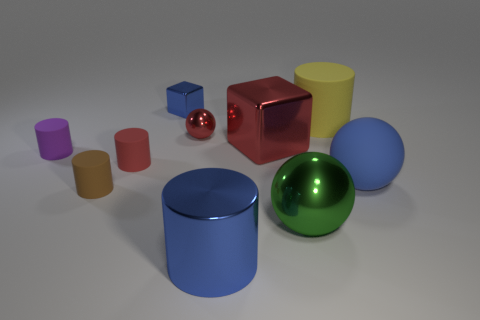Are there any small red objects of the same shape as the big green metallic object?
Offer a terse response. Yes. Is the material of the small brown object the same as the big blue thing that is on the right side of the large blue shiny cylinder?
Ensure brevity in your answer.  Yes. There is a shiny ball behind the rubber object that is left of the tiny cylinder that is in front of the big blue sphere; what color is it?
Give a very brief answer. Red. What is the material of the green thing that is the same size as the rubber ball?
Your answer should be compact. Metal. What number of purple cylinders have the same material as the blue ball?
Offer a terse response. 1. There is a ball in front of the brown object; is it the same size as the sphere that is left of the large metallic sphere?
Keep it short and to the point. No. There is a ball behind the big red metal thing; what is its color?
Keep it short and to the point. Red. There is a cube that is the same color as the large rubber ball; what is its material?
Offer a very short reply. Metal. What number of large shiny cylinders have the same color as the small metallic ball?
Your answer should be very brief. 0. Do the red matte cylinder and the block that is in front of the tiny blue metal block have the same size?
Your answer should be very brief. No. 